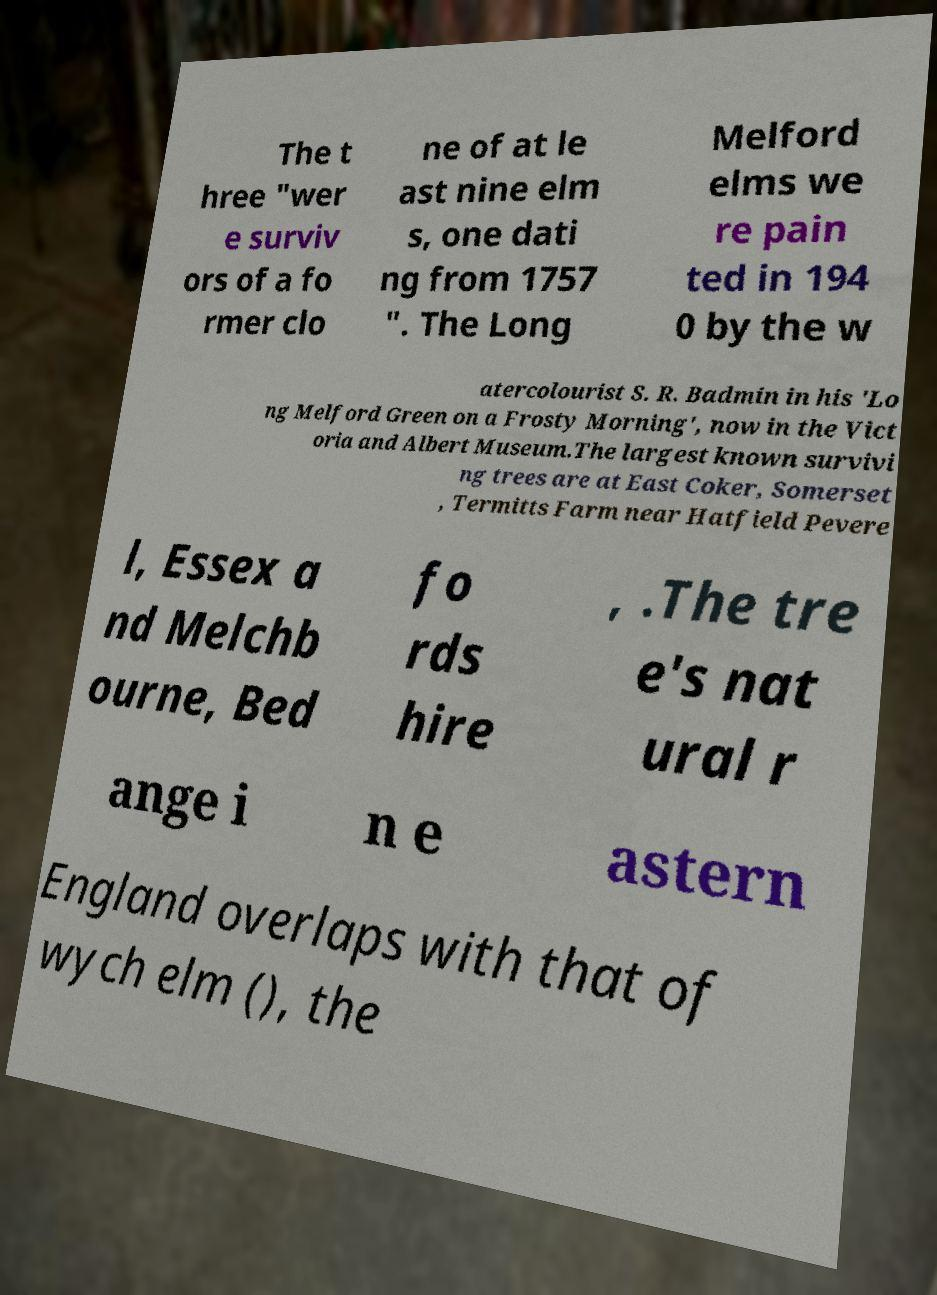What messages or text are displayed in this image? I need them in a readable, typed format. The t hree "wer e surviv ors of a fo rmer clo ne of at le ast nine elm s, one dati ng from 1757 ". The Long Melford elms we re pain ted in 194 0 by the w atercolourist S. R. Badmin in his 'Lo ng Melford Green on a Frosty Morning', now in the Vict oria and Albert Museum.The largest known survivi ng trees are at East Coker, Somerset , Termitts Farm near Hatfield Pevere l, Essex a nd Melchb ourne, Bed fo rds hire , .The tre e's nat ural r ange i n e astern England overlaps with that of wych elm (), the 